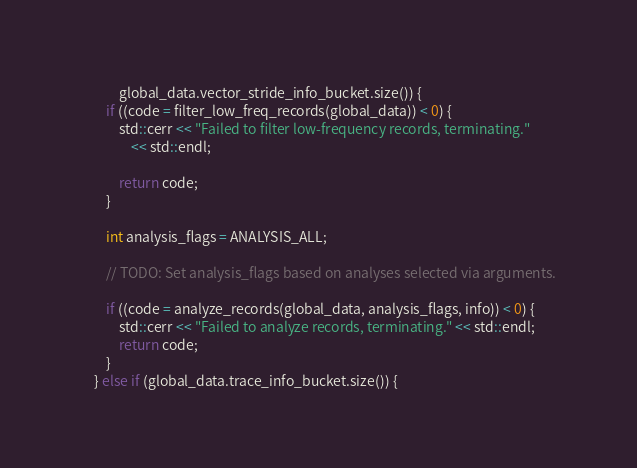Convert code to text. <code><loc_0><loc_0><loc_500><loc_500><_C++_>            global_data.vector_stride_info_bucket.size()) {
        if ((code = filter_low_freq_records(global_data)) < 0) {
            std::cerr << "Failed to filter low-frequency records, terminating."
                << std::endl;

            return code;
        }

        int analysis_flags = ANALYSIS_ALL;

        // TODO: Set analysis_flags based on analyses selected via arguments.

        if ((code = analyze_records(global_data, analysis_flags, info)) < 0) {
            std::cerr << "Failed to analyze records, terminating." << std::endl;
            return code;
        }
    } else if (global_data.trace_info_bucket.size()) {</code> 